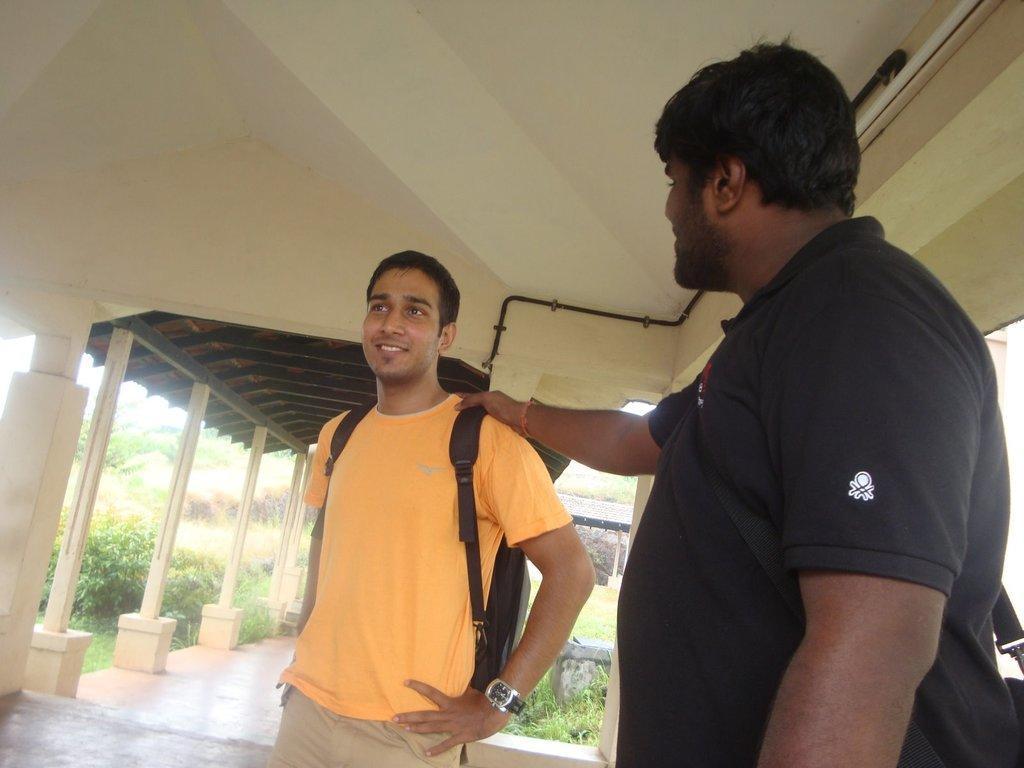Please provide a concise description of this image. In this image we can see two men standing, a person is wearing a backpack and in the background there are pole, shed, plants and grass and there is a rod attached to the wall. 